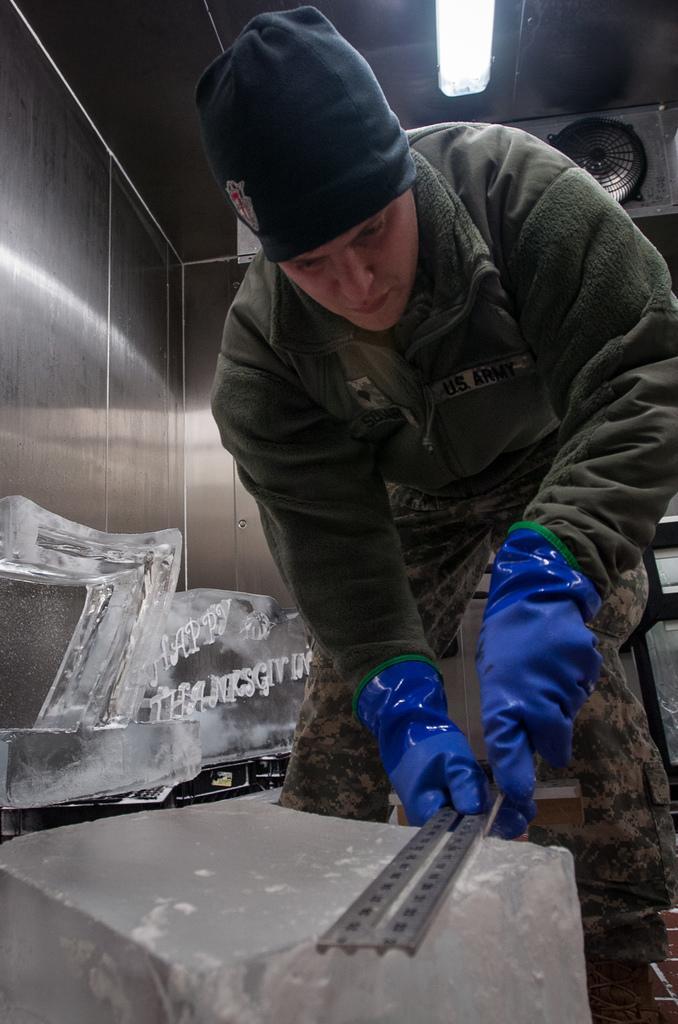Describe this image in one or two sentences. In this image, I can see the man standing and holding an object. I think these are the ice sculptures. At the top of the image, It looks like a tube light and an exhaust fan. 